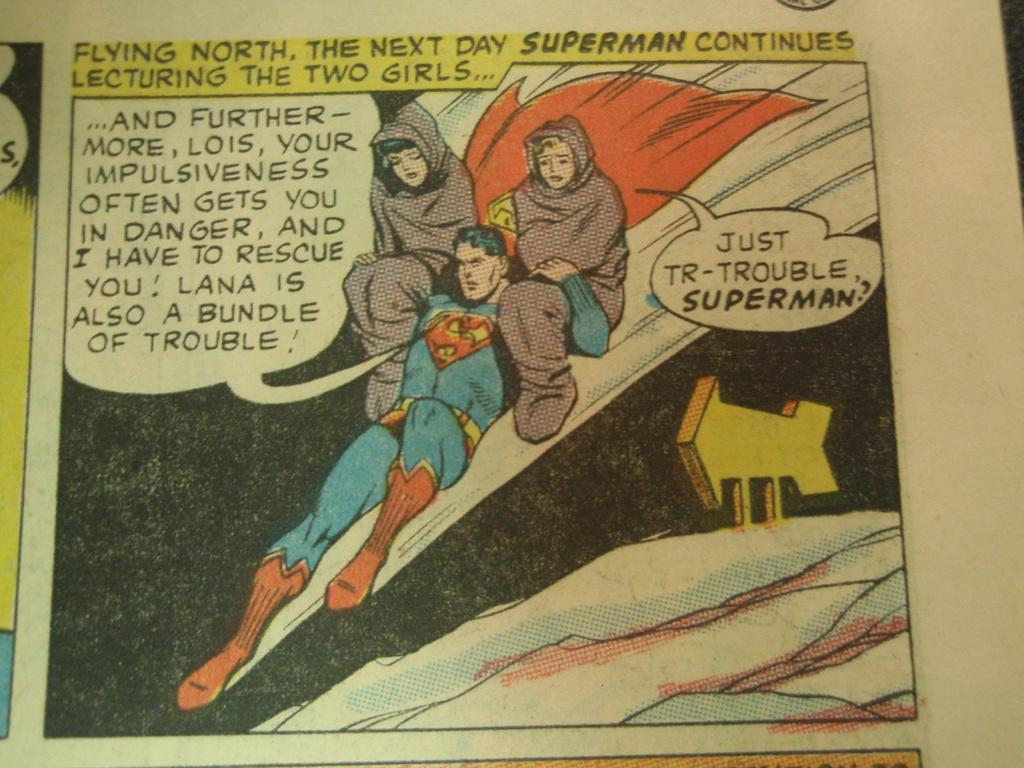<image>
Provide a brief description of the given image. A Superman comic book page shows Superman lecturing two girls he rescued. 